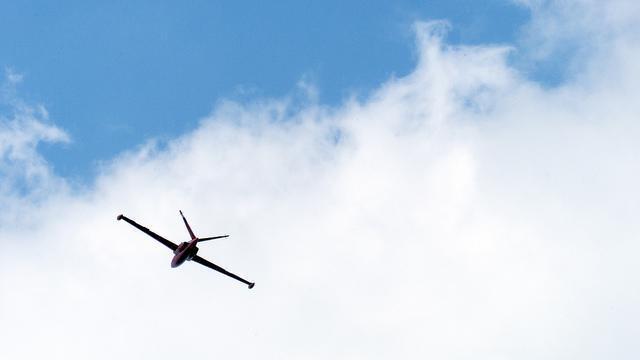How many planes are in the air?
Give a very brief answer. 1. How many planes do you see?
Give a very brief answer. 1. How many planes are there?
Give a very brief answer. 1. 